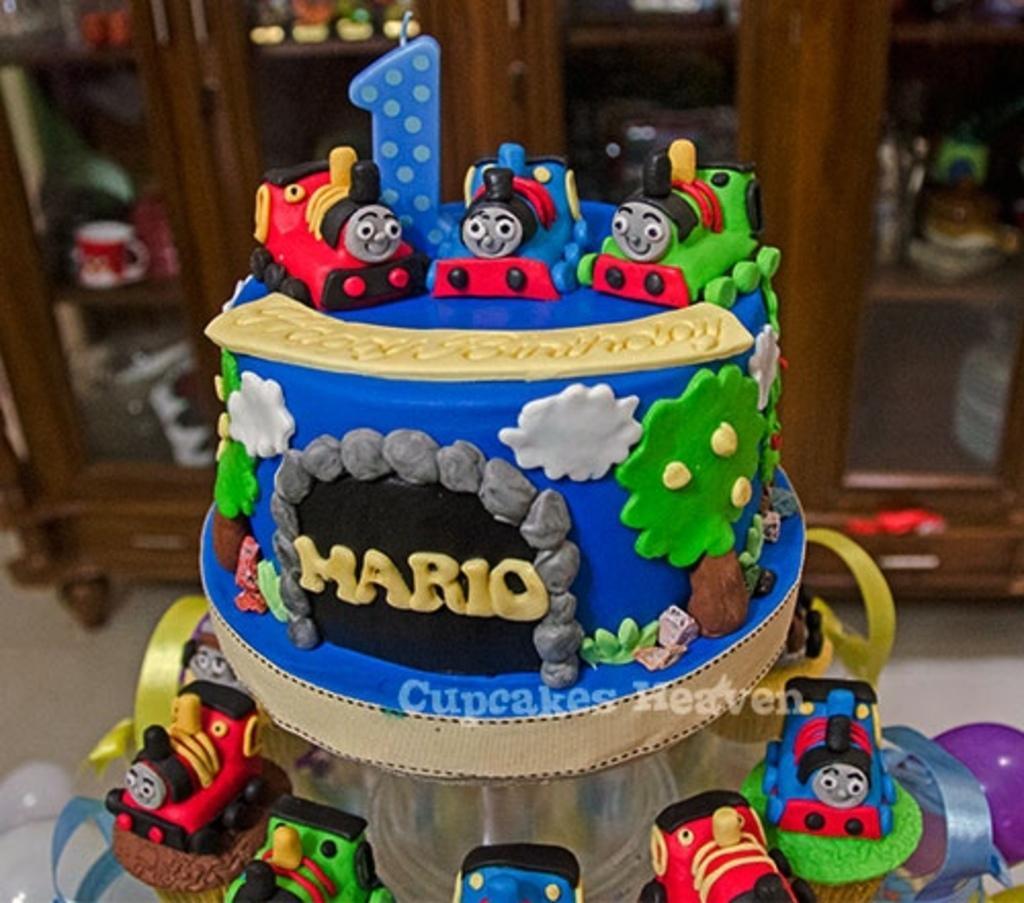Can you describe this image briefly? In this image we can see many objects placed in the cupboards. There are few balloons in the image. There is a cake in the image. 